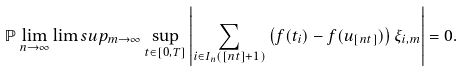<formula> <loc_0><loc_0><loc_500><loc_500>\mathbb { P } \lim _ { n \rightarrow \infty } \lim s u p _ { m \rightarrow \infty } \sup _ { t \in [ 0 , T ] } \left | \sum _ { i \in I _ { n } ( [ n t ] + 1 ) } \left ( f ( t _ { i } ) - f ( u _ { [ n t ] } ) \right ) \xi _ { i , m } \right | = 0 .</formula> 